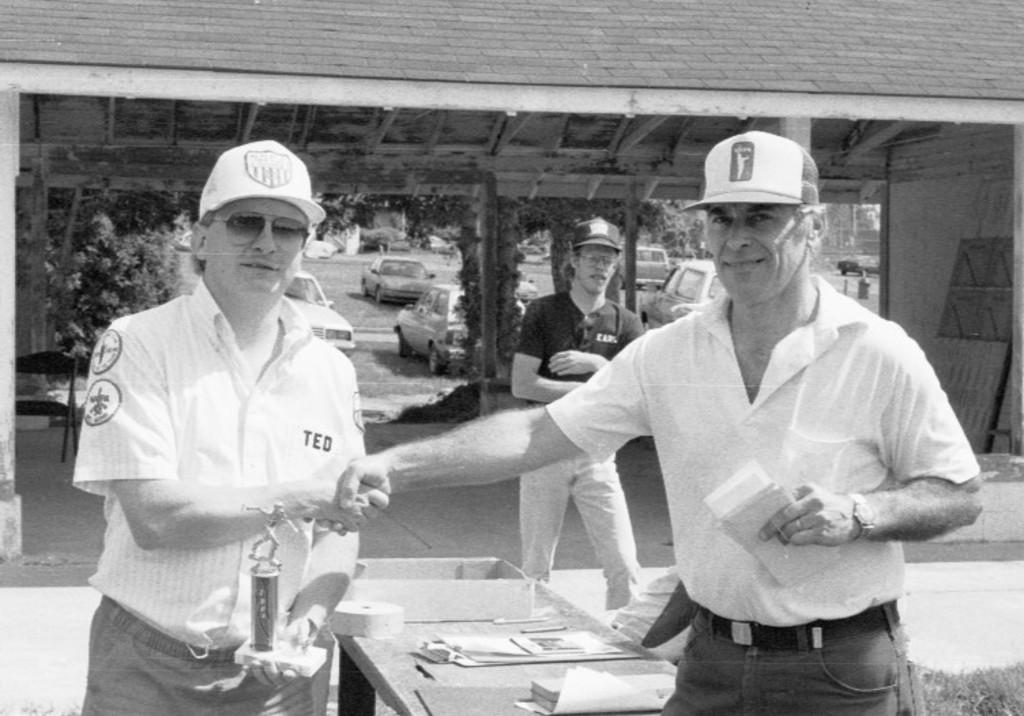Describe this image in one or two sentences. This picture shows few men standing and they wore caps on their heads and couple of men shaking hands and we see man holding a memento in his hand another man holding papers in his hand and we see cars parked on the back and we see trees and a building and we see two men wore sunglasses on their faces and we see papers on the table. 